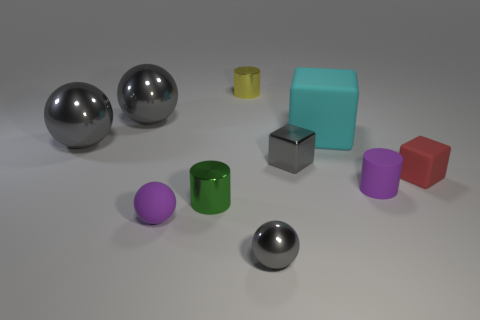Are there any other tiny objects that have the same shape as the tiny yellow object? Yes, there is a tiny green object with a cylindrical shape that matches the shape of the tiny yellow object. 